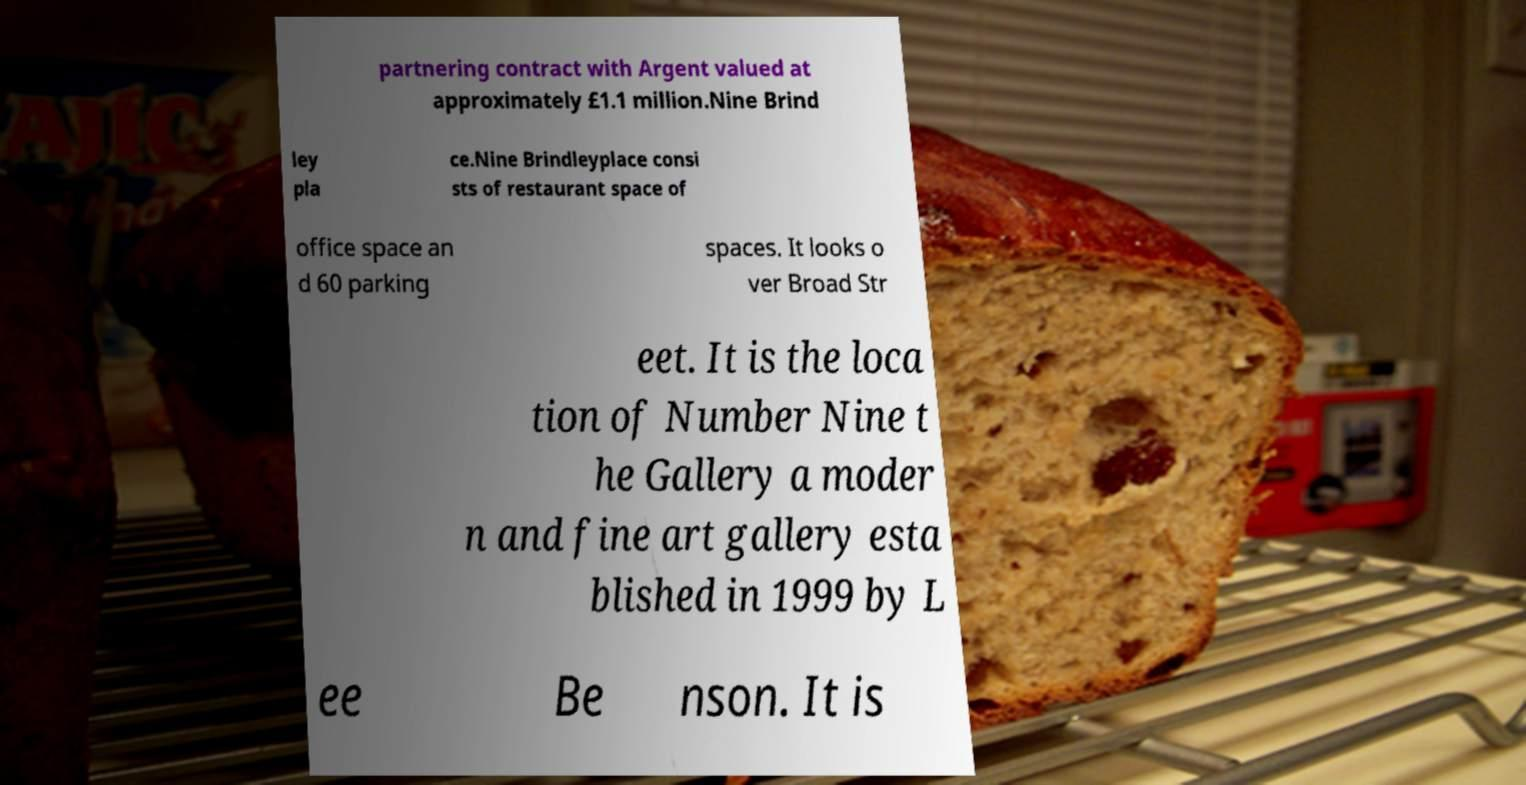Please identify and transcribe the text found in this image. partnering contract with Argent valued at approximately £1.1 million.Nine Brind ley pla ce.Nine Brindleyplace consi sts of restaurant space of office space an d 60 parking spaces. It looks o ver Broad Str eet. It is the loca tion of Number Nine t he Gallery a moder n and fine art gallery esta blished in 1999 by L ee Be nson. It is 